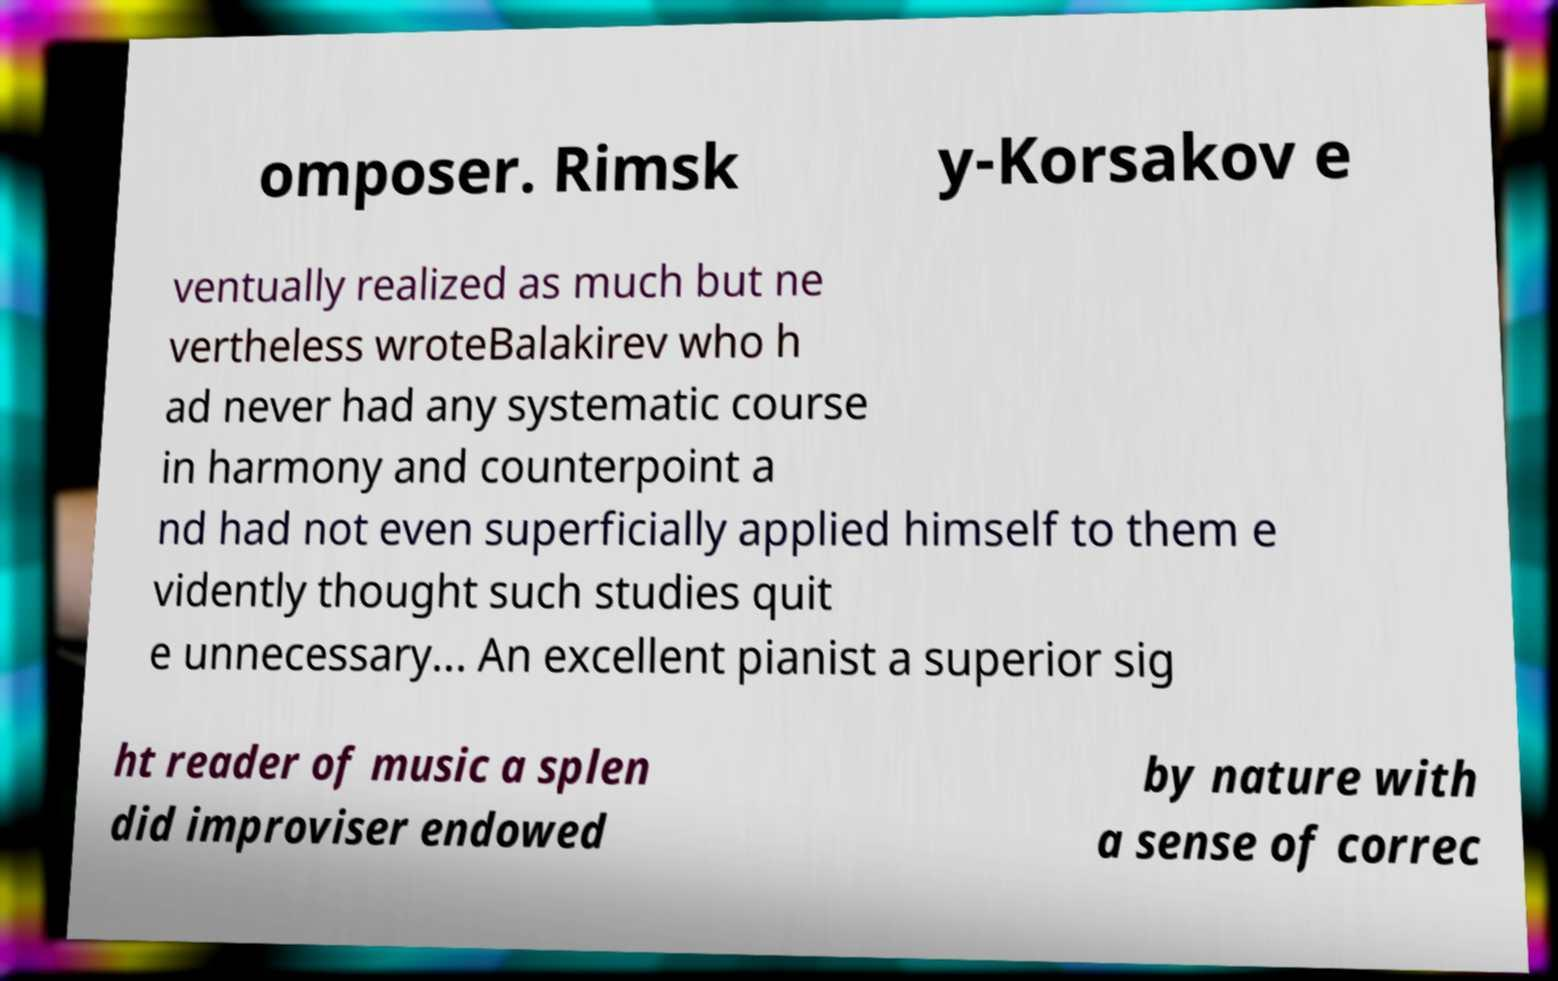There's text embedded in this image that I need extracted. Can you transcribe it verbatim? omposer. Rimsk y-Korsakov e ventually realized as much but ne vertheless wroteBalakirev who h ad never had any systematic course in harmony and counterpoint a nd had not even superficially applied himself to them e vidently thought such studies quit e unnecessary... An excellent pianist a superior sig ht reader of music a splen did improviser endowed by nature with a sense of correc 